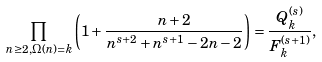Convert formula to latex. <formula><loc_0><loc_0><loc_500><loc_500>\prod _ { n \geq 2 , \Omega ( n ) = k } \left ( 1 + \frac { n + 2 } { n ^ { s + 2 } + n ^ { s + 1 } - 2 n - 2 } \right ) = \frac { Q _ { k } ^ { ( s ) } } { F _ { k } ^ { ( s + 1 ) } } ,</formula> 